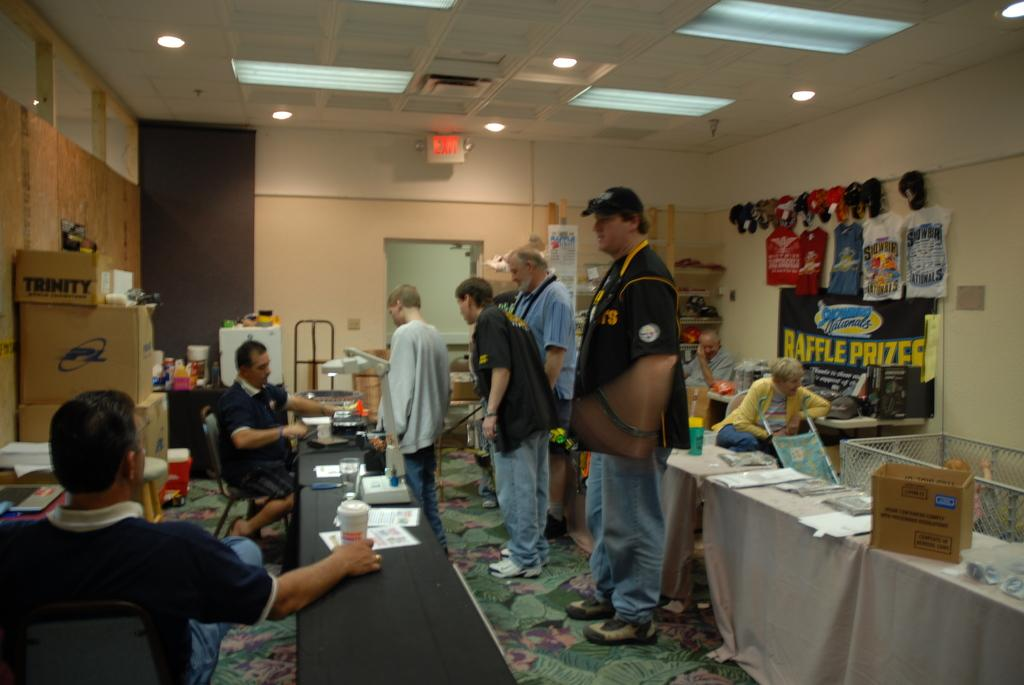What are the two men on the left side of the image doing? The two men are sitting on stools on the left side of the image. What is happening in the middle of the image? There are people standing in the middle of the image. What can be seen at the top of the image? Ceiling lights are visible at the top of the image. What type of ink is being used by the pump in the image? There is no pump or ink present in the image. 